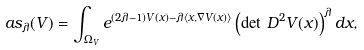Convert formula to latex. <formula><loc_0><loc_0><loc_500><loc_500>a s _ { \lambda } ( V ) = \int _ { \Omega _ { V } } e ^ { ( 2 \lambda - 1 ) V ( x ) - \lambda \langle x , \nabla V ( x ) \rangle } \left ( \det \, D ^ { 2 } V ( x ) \right ) ^ { \lambda } d x ,</formula> 